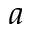Convert formula to latex. <formula><loc_0><loc_0><loc_500><loc_500>a</formula> 